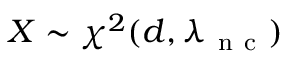Convert formula to latex. <formula><loc_0><loc_0><loc_500><loc_500>X \sim \chi ^ { 2 } ( d , \lambda _ { n c } )</formula> 